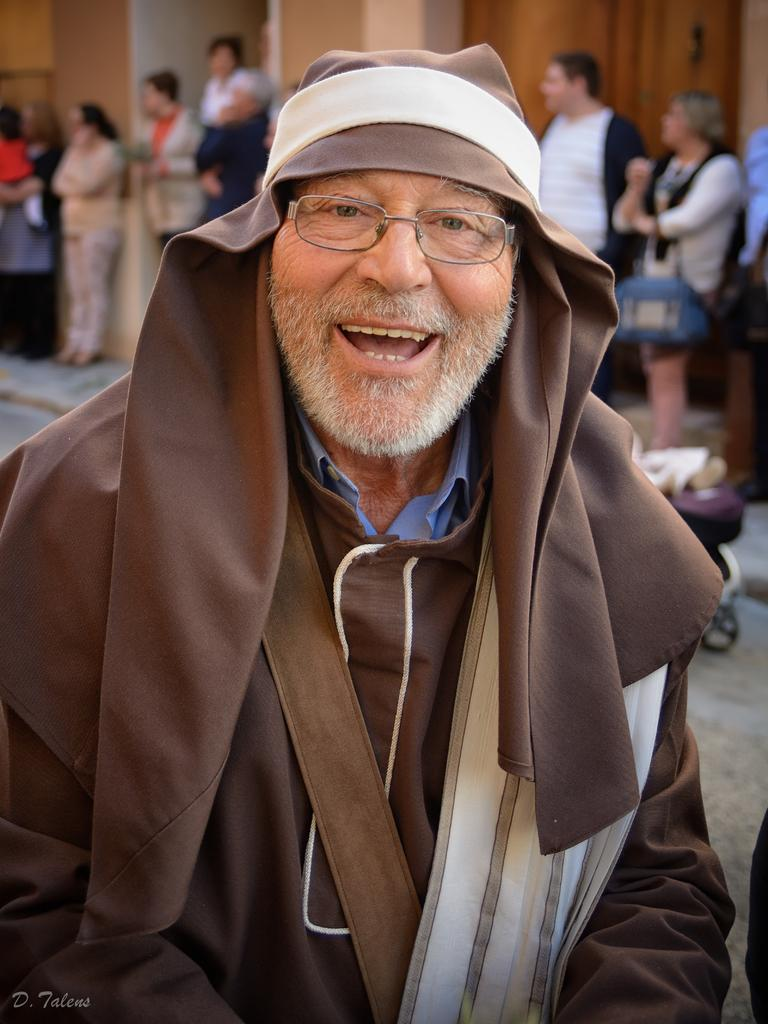What is the man in the image doing? The man in the image is standing and smiling. What can be seen in the background of the image? There are groups of people standing in the background. What type of structure is depicted in the image? The image appears to depict a building. Is there any additional information or marking on the image? Yes, there is a watermark on the image. What type of quiver is the man holding in the image? There is no quiver present in the image; the man is simply standing and smiling. 